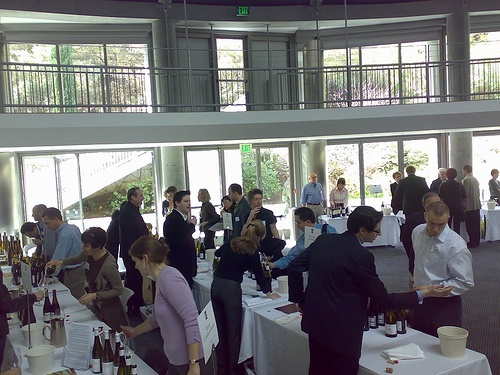Describe the objects in this image and their specific colors. I can see people in black and gray tones, people in black, gray, white, and darkgray tones, dining table in black and gray tones, dining table in black, darkgray, and gray tones, and people in black and gray tones in this image. 